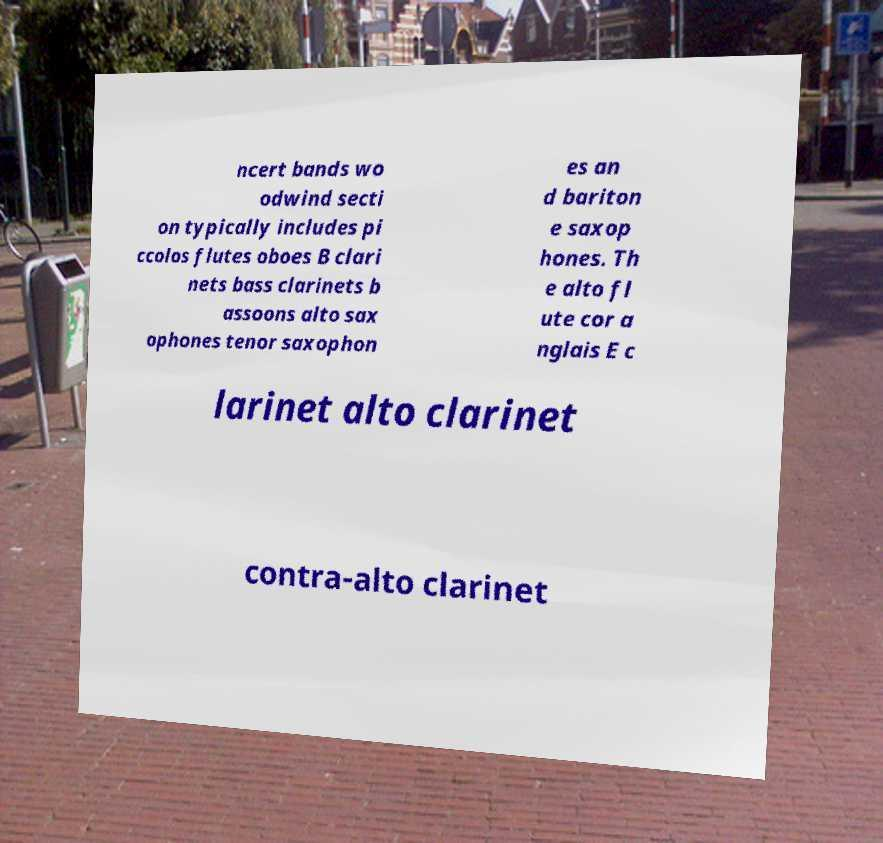Could you extract and type out the text from this image? ncert bands wo odwind secti on typically includes pi ccolos flutes oboes B clari nets bass clarinets b assoons alto sax ophones tenor saxophon es an d bariton e saxop hones. Th e alto fl ute cor a nglais E c larinet alto clarinet contra-alto clarinet 